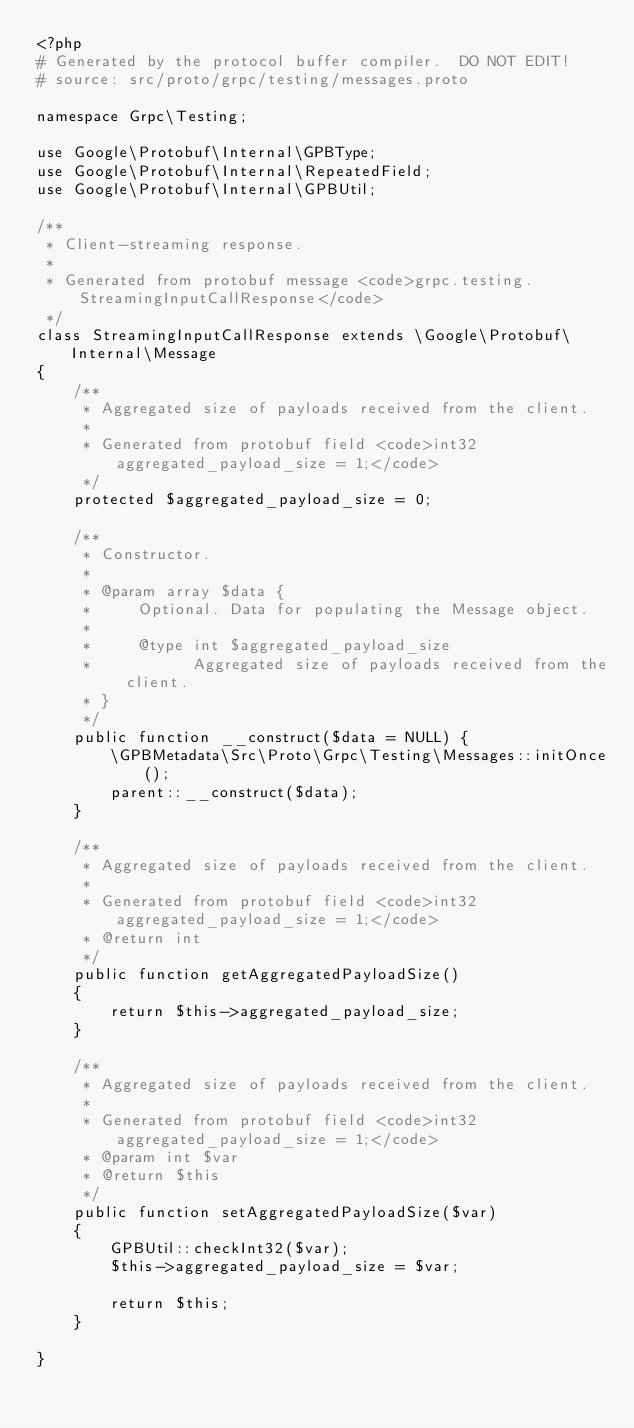Convert code to text. <code><loc_0><loc_0><loc_500><loc_500><_PHP_><?php
# Generated by the protocol buffer compiler.  DO NOT EDIT!
# source: src/proto/grpc/testing/messages.proto

namespace Grpc\Testing;

use Google\Protobuf\Internal\GPBType;
use Google\Protobuf\Internal\RepeatedField;
use Google\Protobuf\Internal\GPBUtil;

/**
 * Client-streaming response.
 *
 * Generated from protobuf message <code>grpc.testing.StreamingInputCallResponse</code>
 */
class StreamingInputCallResponse extends \Google\Protobuf\Internal\Message
{
    /**
     * Aggregated size of payloads received from the client.
     *
     * Generated from protobuf field <code>int32 aggregated_payload_size = 1;</code>
     */
    protected $aggregated_payload_size = 0;

    /**
     * Constructor.
     *
     * @param array $data {
     *     Optional. Data for populating the Message object.
     *
     *     @type int $aggregated_payload_size
     *           Aggregated size of payloads received from the client.
     * }
     */
    public function __construct($data = NULL) {
        \GPBMetadata\Src\Proto\Grpc\Testing\Messages::initOnce();
        parent::__construct($data);
    }

    /**
     * Aggregated size of payloads received from the client.
     *
     * Generated from protobuf field <code>int32 aggregated_payload_size = 1;</code>
     * @return int
     */
    public function getAggregatedPayloadSize()
    {
        return $this->aggregated_payload_size;
    }

    /**
     * Aggregated size of payloads received from the client.
     *
     * Generated from protobuf field <code>int32 aggregated_payload_size = 1;</code>
     * @param int $var
     * @return $this
     */
    public function setAggregatedPayloadSize($var)
    {
        GPBUtil::checkInt32($var);
        $this->aggregated_payload_size = $var;

        return $this;
    }

}

</code> 